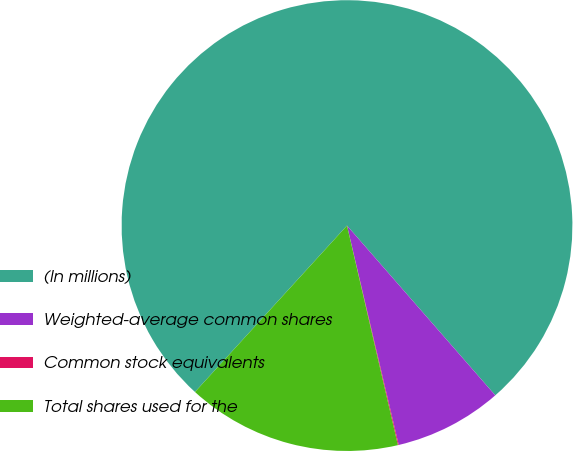Convert chart to OTSL. <chart><loc_0><loc_0><loc_500><loc_500><pie_chart><fcel>(In millions)<fcel>Weighted-average common shares<fcel>Common stock equivalents<fcel>Total shares used for the<nl><fcel>76.79%<fcel>7.74%<fcel>0.06%<fcel>15.41%<nl></chart> 